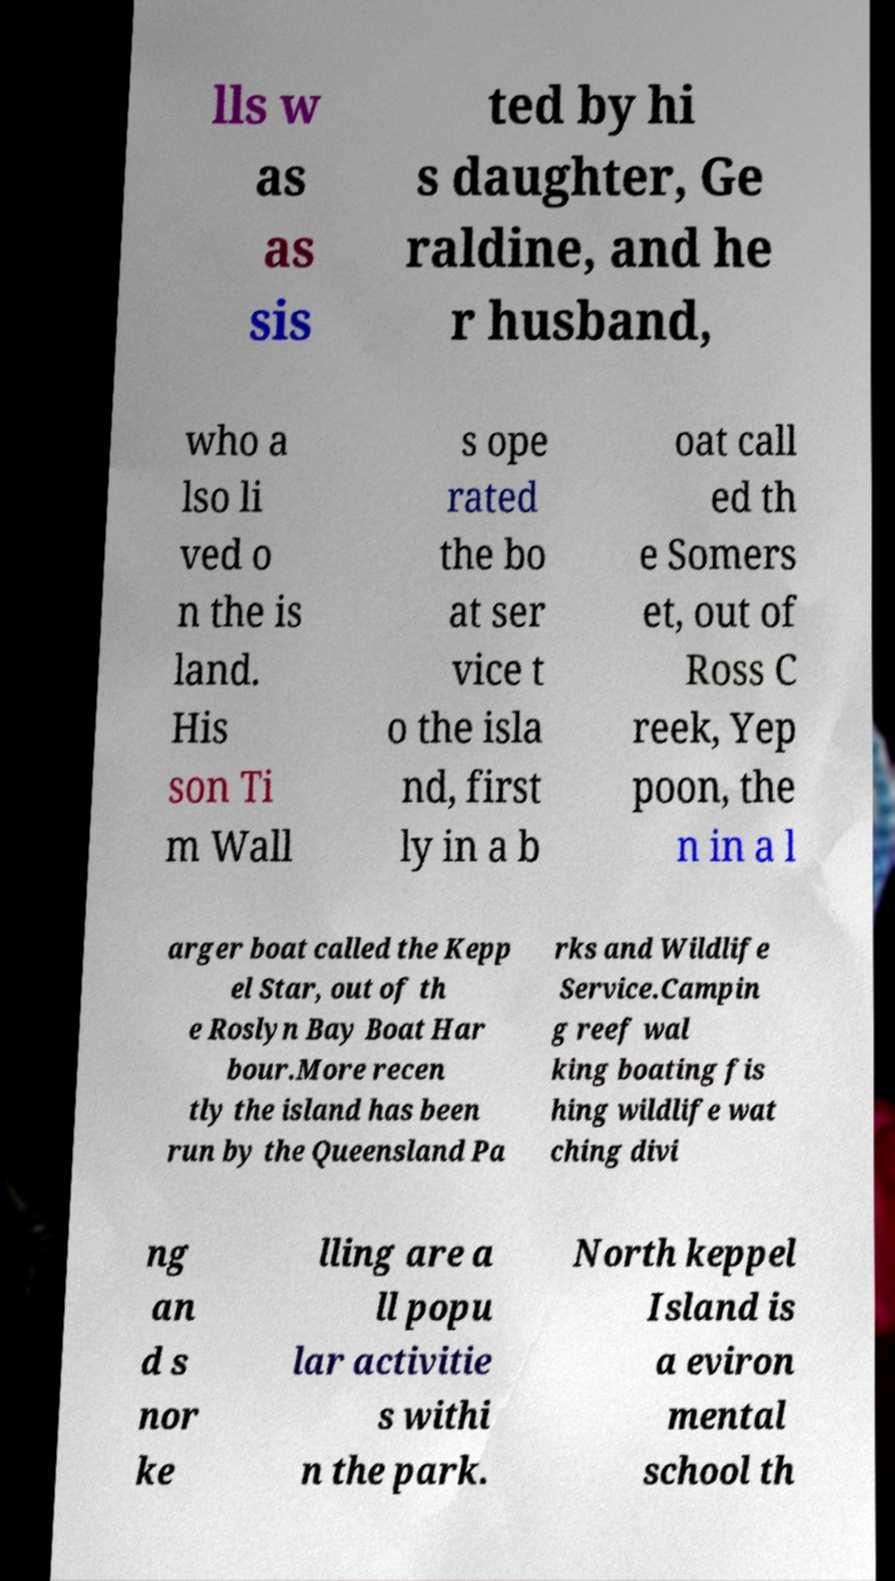Please identify and transcribe the text found in this image. lls w as as sis ted by hi s daughter, Ge raldine, and he r husband, who a lso li ved o n the is land. His son Ti m Wall s ope rated the bo at ser vice t o the isla nd, first ly in a b oat call ed th e Somers et, out of Ross C reek, Yep poon, the n in a l arger boat called the Kepp el Star, out of th e Roslyn Bay Boat Har bour.More recen tly the island has been run by the Queensland Pa rks and Wildlife Service.Campin g reef wal king boating fis hing wildlife wat ching divi ng an d s nor ke lling are a ll popu lar activitie s withi n the park. North keppel Island is a eviron mental school th 